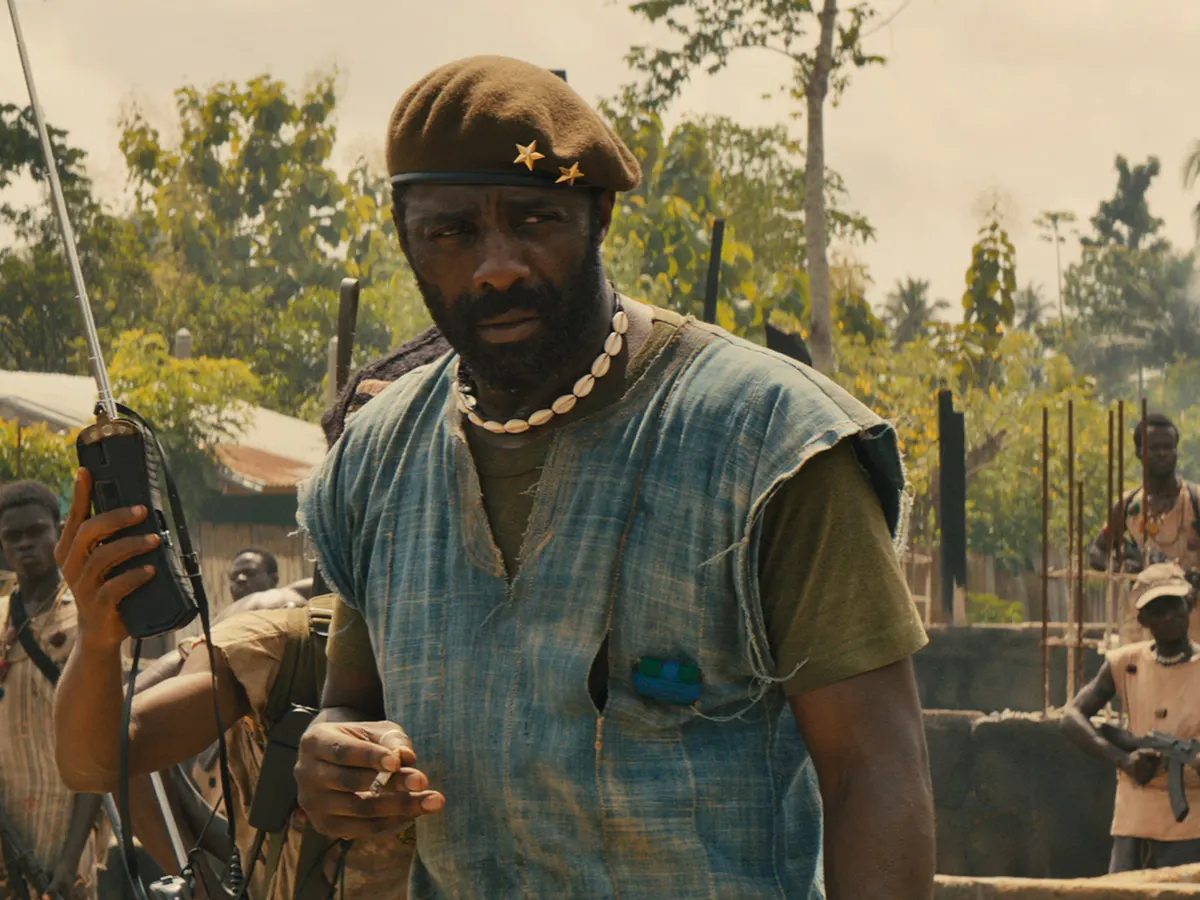Imagine if this scene was transposed into a science fiction setting. How would it appear? In a science fiction setting, the character could be standing in a post-apocalyptic or dystopian landscape, with crumbling futuristic architecture and bioluminescent vegetation providing an eerie glow. His attire might be upgraded to advanced, tactical armor, and the green vest could incorporate holographic interfaces. The beret might be replaced by a sleek helmet featuring heads-up displays, while the walkie-talkie would transform into a wrist-mounted communication device with holographic screens. The gun would be a sleek, plasma-based weapon or an energy rifle. The soldiers behind him could be wearing exoskeleton suits, enhancing their physical capabilities. Robots or drones might hover nearby, augmenting their tactical support. The landscape could blend elements of decay with advanced, alien technology, creating an atmosphere of both survival and high-tech warfare. 